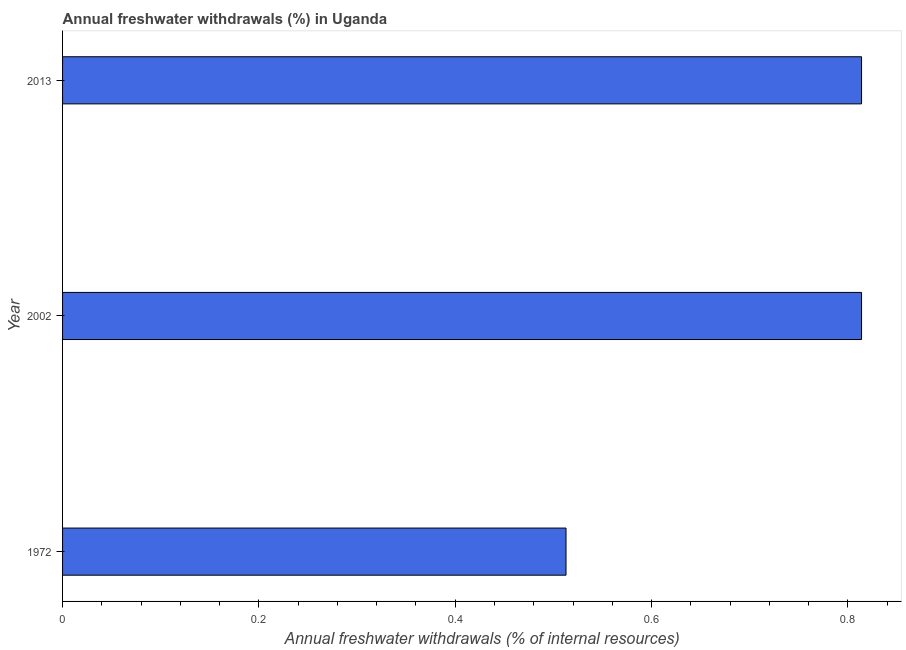Does the graph contain any zero values?
Your answer should be very brief. No. What is the title of the graph?
Ensure brevity in your answer.  Annual freshwater withdrawals (%) in Uganda. What is the label or title of the X-axis?
Your answer should be compact. Annual freshwater withdrawals (% of internal resources). What is the annual freshwater withdrawals in 2013?
Make the answer very short. 0.81. Across all years, what is the maximum annual freshwater withdrawals?
Ensure brevity in your answer.  0.81. Across all years, what is the minimum annual freshwater withdrawals?
Ensure brevity in your answer.  0.51. What is the sum of the annual freshwater withdrawals?
Your answer should be very brief. 2.14. What is the difference between the annual freshwater withdrawals in 1972 and 2002?
Make the answer very short. -0.3. What is the average annual freshwater withdrawals per year?
Your answer should be very brief. 0.71. What is the median annual freshwater withdrawals?
Offer a terse response. 0.81. In how many years, is the annual freshwater withdrawals greater than 0.72 %?
Give a very brief answer. 2. Do a majority of the years between 1972 and 2013 (inclusive) have annual freshwater withdrawals greater than 0.48 %?
Your response must be concise. Yes. Is the difference between the annual freshwater withdrawals in 1972 and 2013 greater than the difference between any two years?
Your answer should be compact. Yes. What is the difference between the highest and the second highest annual freshwater withdrawals?
Provide a short and direct response. 0. Is the sum of the annual freshwater withdrawals in 1972 and 2013 greater than the maximum annual freshwater withdrawals across all years?
Make the answer very short. Yes. How many years are there in the graph?
Provide a short and direct response. 3. What is the difference between two consecutive major ticks on the X-axis?
Your answer should be very brief. 0.2. Are the values on the major ticks of X-axis written in scientific E-notation?
Offer a terse response. No. What is the Annual freshwater withdrawals (% of internal resources) in 1972?
Ensure brevity in your answer.  0.51. What is the Annual freshwater withdrawals (% of internal resources) of 2002?
Keep it short and to the point. 0.81. What is the Annual freshwater withdrawals (% of internal resources) of 2013?
Your response must be concise. 0.81. What is the difference between the Annual freshwater withdrawals (% of internal resources) in 1972 and 2002?
Your answer should be very brief. -0.3. What is the difference between the Annual freshwater withdrawals (% of internal resources) in 1972 and 2013?
Your answer should be compact. -0.3. What is the difference between the Annual freshwater withdrawals (% of internal resources) in 2002 and 2013?
Provide a succinct answer. 0. What is the ratio of the Annual freshwater withdrawals (% of internal resources) in 1972 to that in 2002?
Offer a very short reply. 0.63. What is the ratio of the Annual freshwater withdrawals (% of internal resources) in 1972 to that in 2013?
Your response must be concise. 0.63. What is the ratio of the Annual freshwater withdrawals (% of internal resources) in 2002 to that in 2013?
Make the answer very short. 1. 